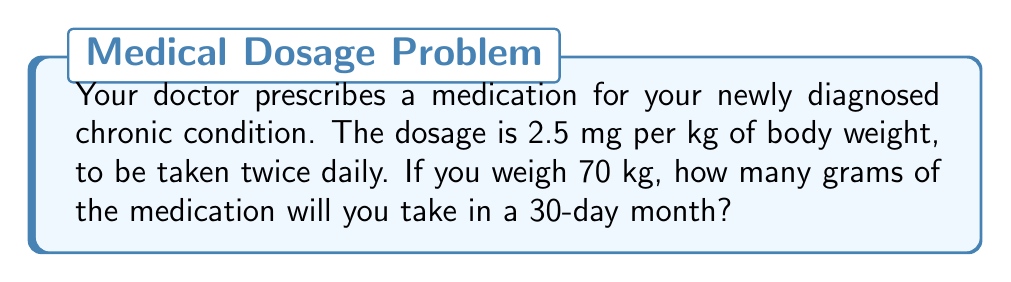Give your solution to this math problem. Let's break this down step-by-step:

1) First, calculate the dose for your weight:
   $2.5 \text{ mg/kg} \times 70 \text{ kg} = 175 \text{ mg}$ per dose

2) You take this twice daily, so the daily amount is:
   $175 \text{ mg} \times 2 = 350 \text{ mg}$ per day

3) For a 30-day month, the total amount is:
   $350 \text{ mg/day} \times 30 \text{ days} = 10,500 \text{ mg}$

4) Now, we need to convert mg to g. We know that:
   $1 \text{ g} = 1000 \text{ mg}$

5) So, to convert 10,500 mg to g, we divide by 1000:
   $$\frac{10,500 \text{ mg}}{1000 \text{ mg/g}} = 10.5 \text{ g}$$

Therefore, in a 30-day month, you will take 10.5 grams of the medication.
Answer: 10.5 g 